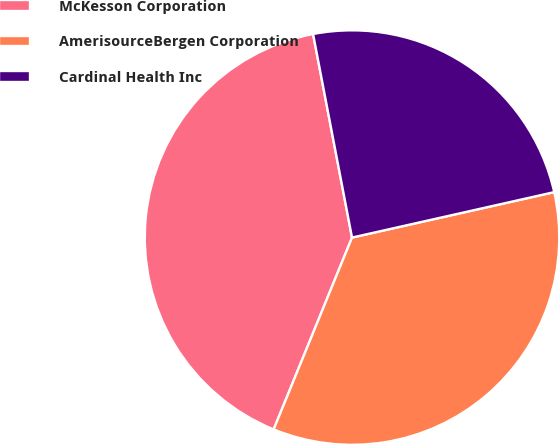Convert chart. <chart><loc_0><loc_0><loc_500><loc_500><pie_chart><fcel>McKesson Corporation<fcel>AmerisourceBergen Corporation<fcel>Cardinal Health Inc<nl><fcel>40.82%<fcel>34.69%<fcel>24.49%<nl></chart> 